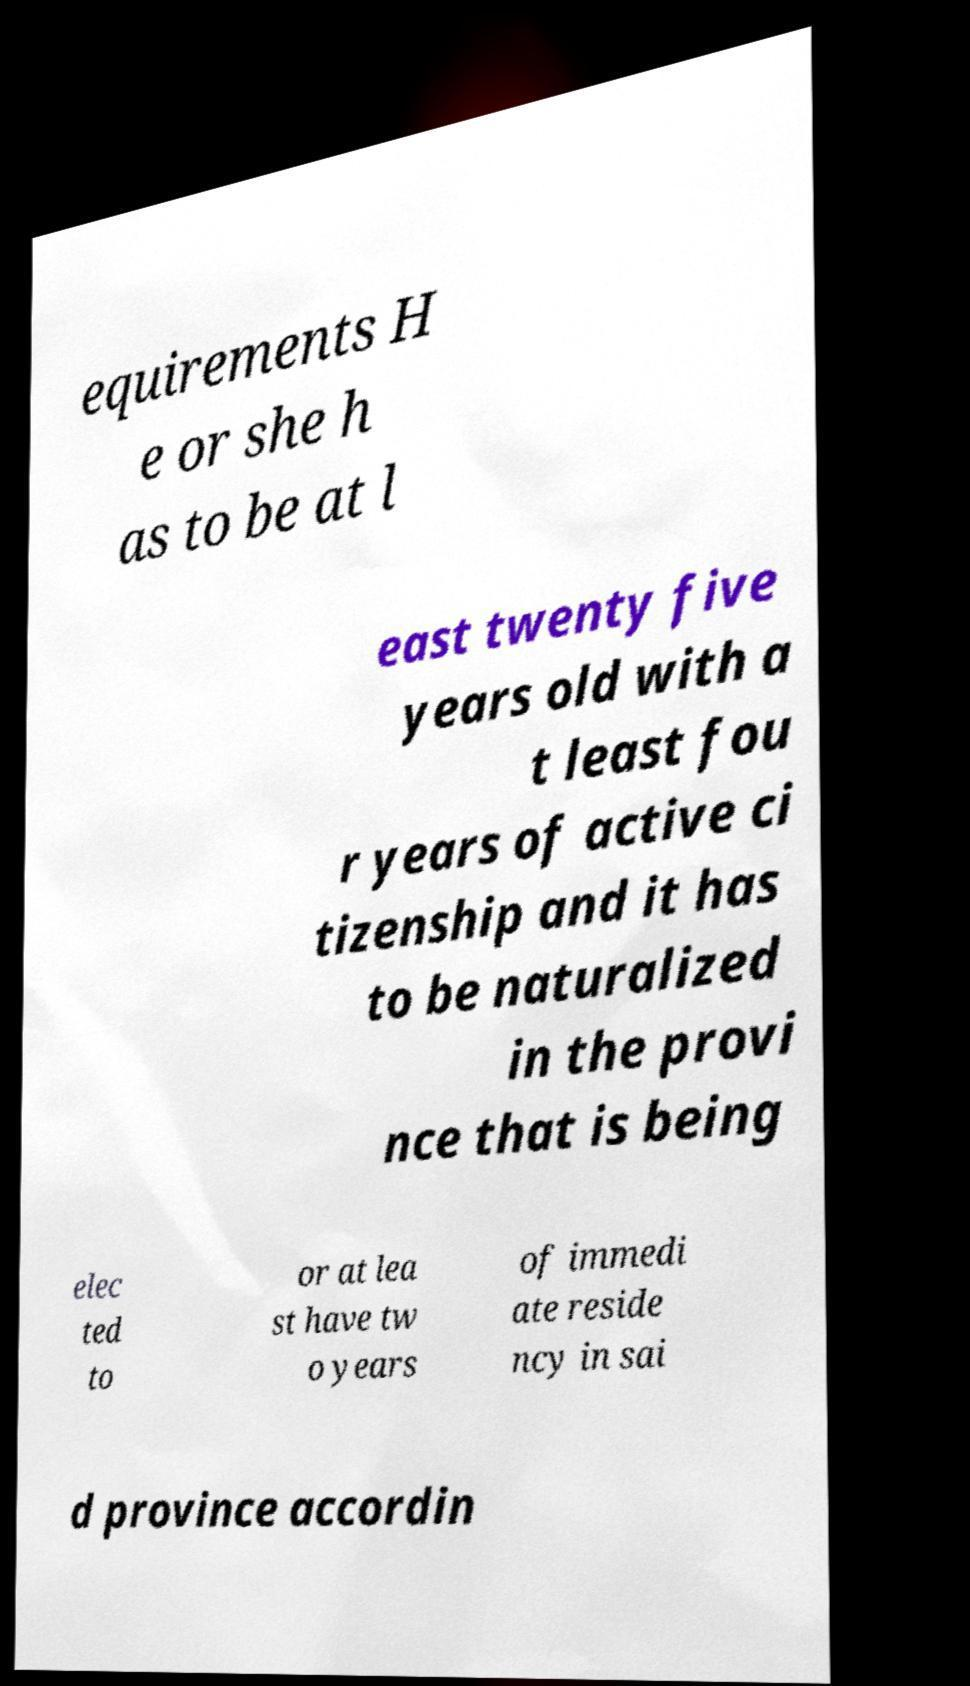Can you accurately transcribe the text from the provided image for me? equirements H e or she h as to be at l east twenty five years old with a t least fou r years of active ci tizenship and it has to be naturalized in the provi nce that is being elec ted to or at lea st have tw o years of immedi ate reside ncy in sai d province accordin 